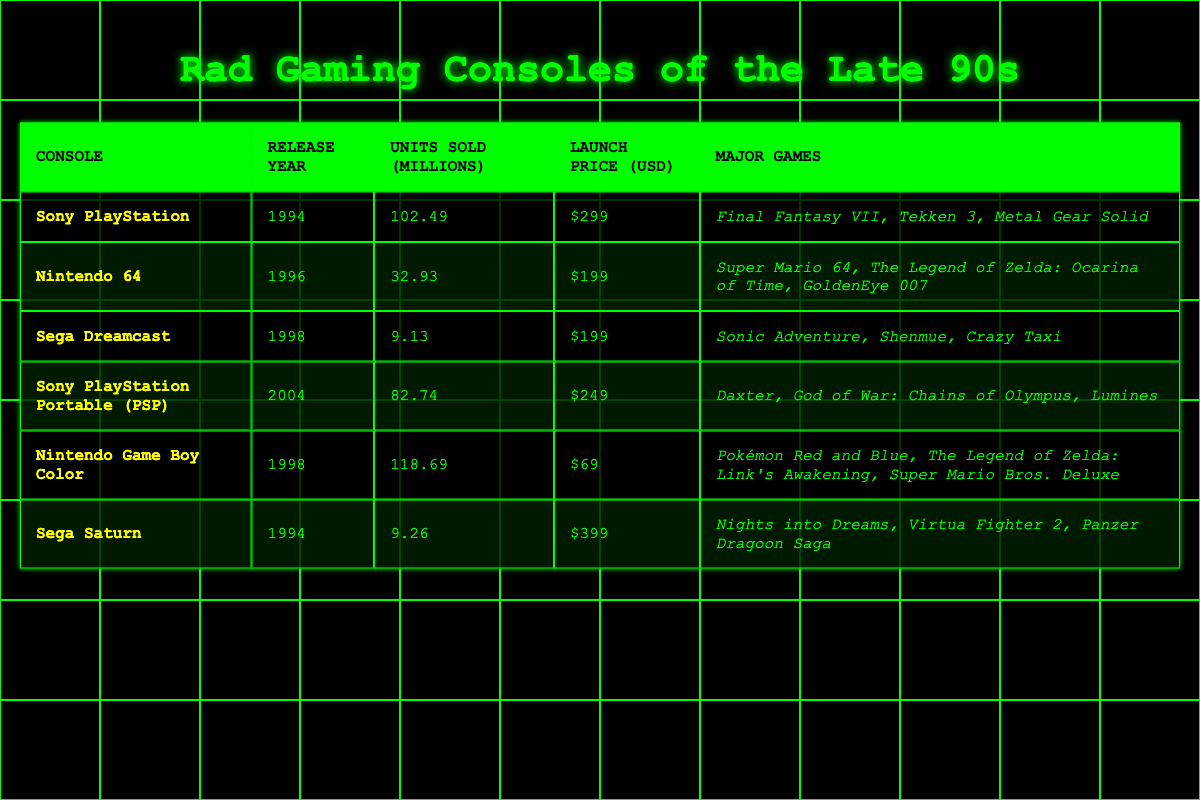What is the highest-selling gaming console in the late 90s? By looking at the "Units Sold (Millions)" column, the Sony PlayStation has the highest value at 102.49 million units sold.
Answer: Sony PlayStation Which console had the lowest launch price? The launch prices of the consoles are listed, and the Nintendo Game Boy Color has the lowest price at $69.
Answer: Nintendo Game Boy Color How many units did the Nintendo 64 sell compared to the Sega Dreamcast? The Nintendo 64 sold 32.93 million units while the Sega Dreamcast sold 9.13 million units. 32.93 - 9.13 = 23.8 million more units sold for the Nintendo 64.
Answer: 23.8 million What is the combined total of units sold for the Sega Saturn and Sega Dreamcast? The Sega Saturn sold 9.26 million units, and the Sega Dreamcast sold 9.13 million units. Adding these gives 9.26 + 9.13 = 18.39 million units combined.
Answer: 18.39 million Did any consoles sell over 100 million units? Checking the "Units Sold (Millions)" column reveals that only the Sony PlayStation sold over 100 million units, with 102.49 million. Therefore, the answer is yes.
Answer: Yes 